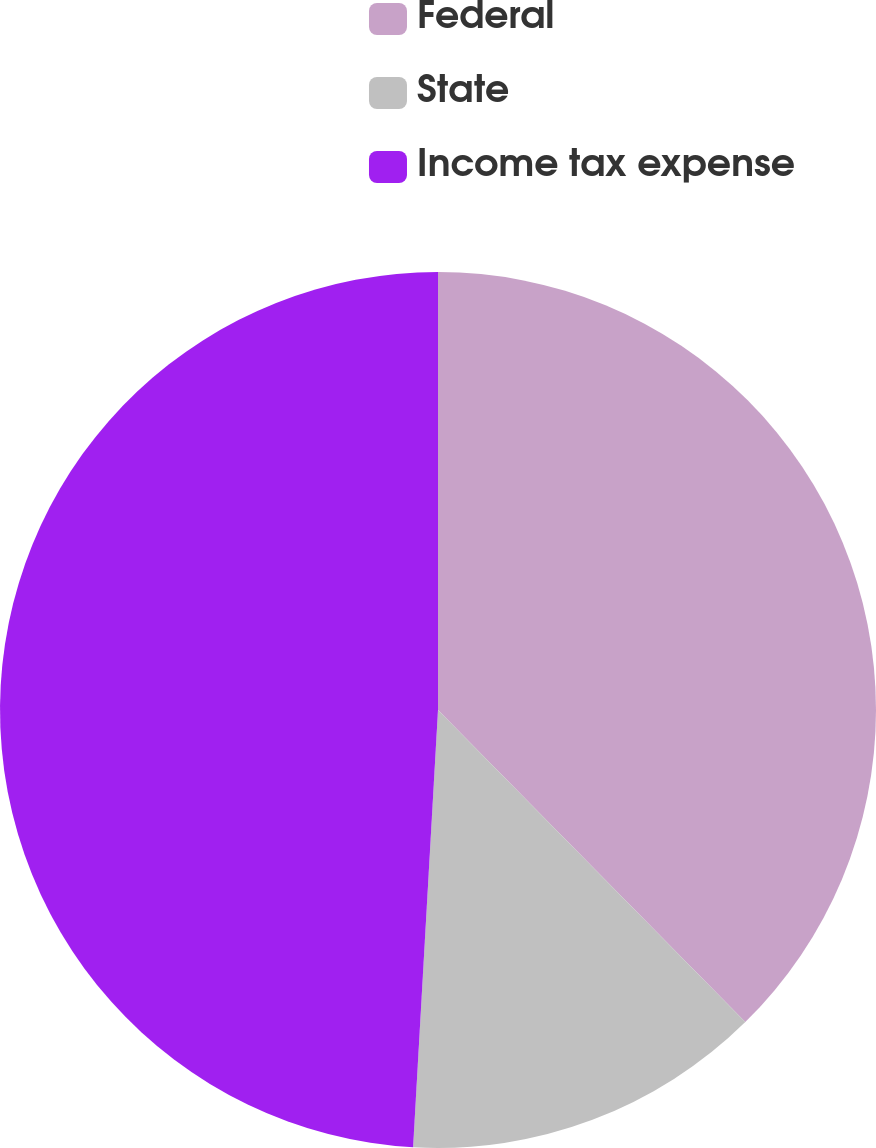Convert chart to OTSL. <chart><loc_0><loc_0><loc_500><loc_500><pie_chart><fcel>Federal<fcel>State<fcel>Income tax expense<nl><fcel>37.62%<fcel>13.28%<fcel>49.09%<nl></chart> 